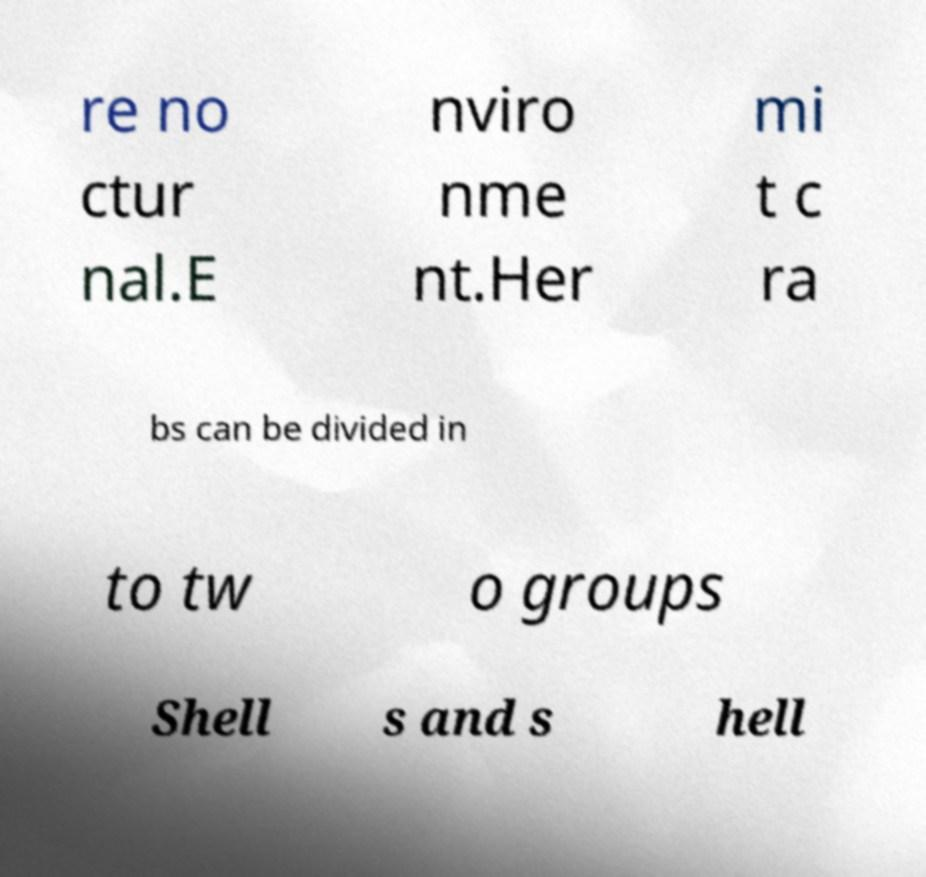Could you extract and type out the text from this image? re no ctur nal.E nviro nme nt.Her mi t c ra bs can be divided in to tw o groups Shell s and s hell 